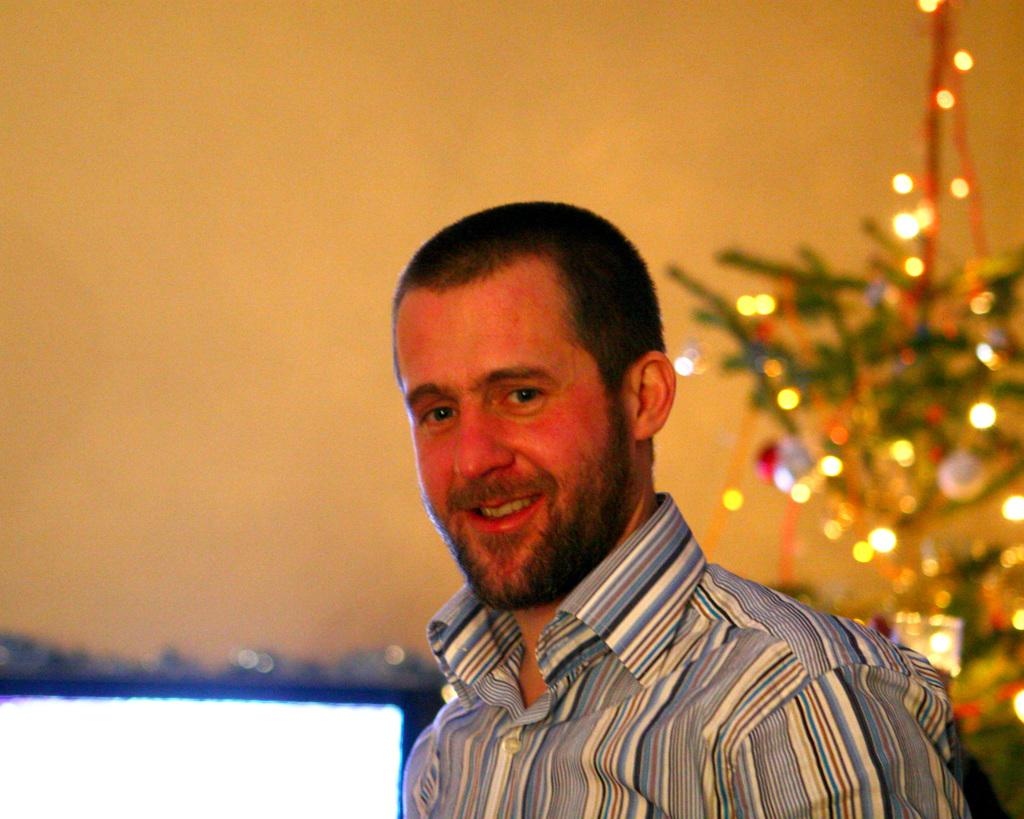Who is present in the image? There is a person in the image. What is the person doing in the image? The person is smiling. What can be seen in the background of the image? There is a Christmas tree with lights in the background of the image. What is visible on the side of the image? There is a wall visible in the image. How many friends are standing on the person's feet in the image? There are no friends standing on the person's feet in the image. What type of burst can be seen coming from the Christmas tree in the image? There is no burst coming from the Christmas tree in the image; it is a static image with lights on the tree. 